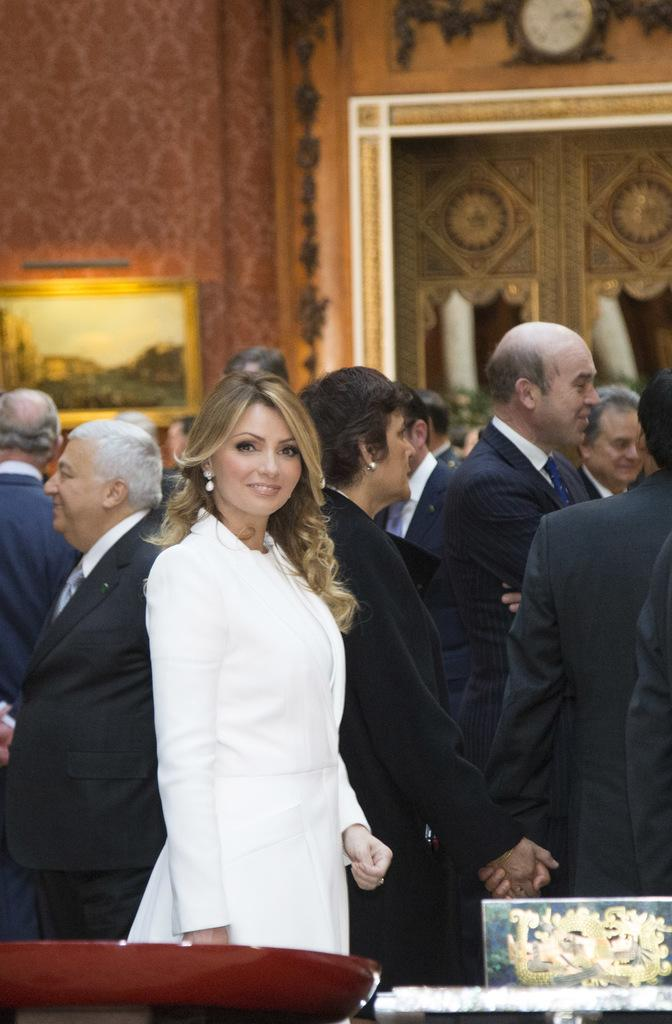What types of people are present in the image? There are men and women standing in the image. Where are the people standing? They are standing on the floor. What can be seen in the background of the image? There are wall hangings and a clock in the background of the image. What type of faucet can be seen in the image? There is no faucet present in the image. Can you tell me how many pens are visible in the image? There are no pens visible in the image. 